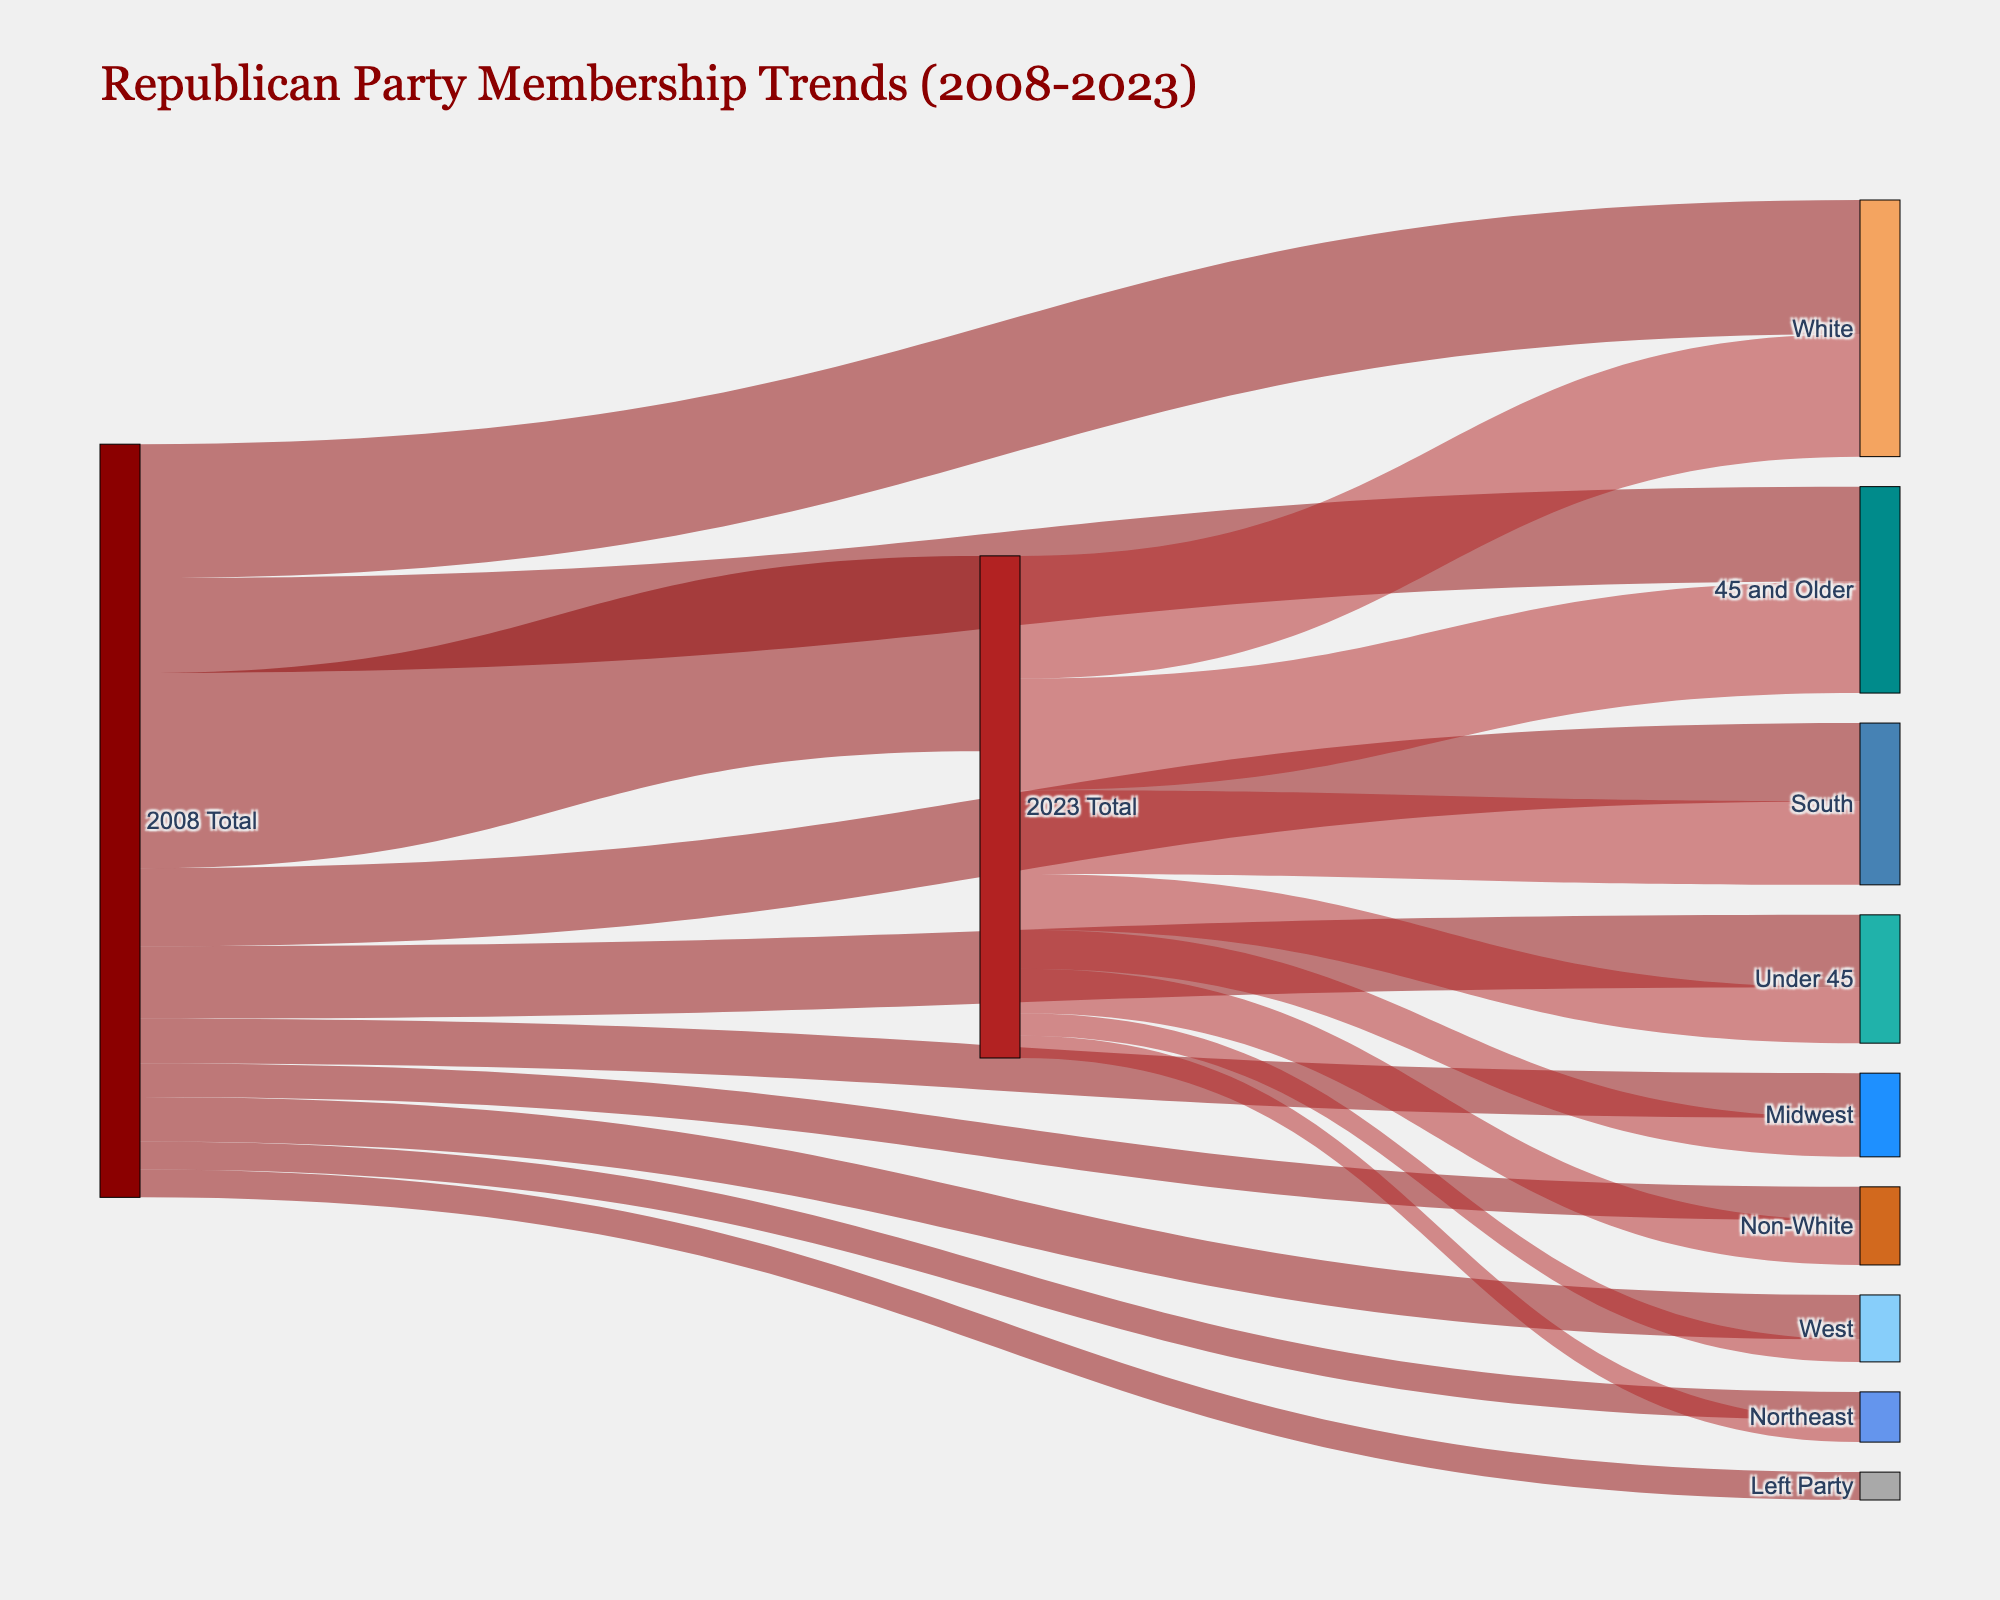What's the total number of Republican Party members in 2023? Refer to the entry where "2008 Total" transitions to "2023 Total" in the figure. The value is given directly.
Answer: 35,000,000 How many members left the Republican Party between 2008 and 2023? Look at the path from "2008 Total" to "Left Party." The value is given directly in the diagram.
Answer: 5,000,000 Which demographic group within the Republican Party increased from 2008 to 2023? Compare the values for "White" and "Non-White" transitioning from "2008 Total" to "2023 Total." "Non-White" increased from 6,000,000 to 8,000,000.
Answer: Non-White Between 2008 and 2023, did the number of Republican members increase or decrease in the Midwest? Compare the values from "2008 Total" to "Midwest" and from "2023 Total" to "Midwest". The numbers decreased from 8,000,000 to 7,000,000.
Answer: Decrease How many Republican Party members are aged 45 and older in 2023? Look at the flow from "2023 Total" to "45 and Older." The value is given directly.
Answer: 20,000,000 Which regional groups saw a decrease in Republican membership between 2008 and 2023? Compare the transition values from both years for "South", "Midwest", "Northeast", and "West." Both "Midwest," "Northeast," and "West" show a decrease.
Answer: Midwest, Northeast, West How does the number of Republican members under 45 in 2008 compare to 2023? Look at the values from "2008 Total" to "Under 45" and from "2023 Total" to "Under 45." Compare 13,000,000 in 2008 and 10,000,000 in 2023.
Answer: Decreased by 3,000,000 Which age demographic saw the largest increase in Republican membership from 2008 to 2023? Compare the transitions to age groups "Under 45" and "45 and Older" from 2008 and 2023. "45 and Older" increased from 17,000,000 to 20,000,000.
Answer: 45 and Older What is the sum of Republican Party members aged under 45 and 45 and older in 2023? Add the values for "Under 45" and "45 and Older" from the "2023 Total." 10,000,000 + 20,000,000 = 30,000,000.
Answer: 30,000,000 